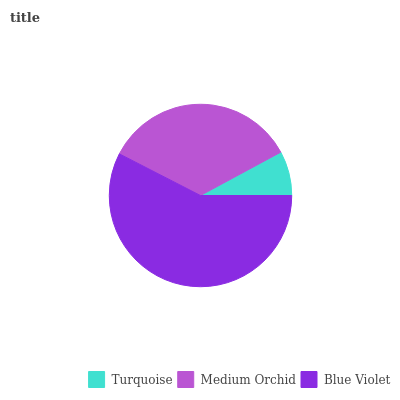Is Turquoise the minimum?
Answer yes or no. Yes. Is Blue Violet the maximum?
Answer yes or no. Yes. Is Medium Orchid the minimum?
Answer yes or no. No. Is Medium Orchid the maximum?
Answer yes or no. No. Is Medium Orchid greater than Turquoise?
Answer yes or no. Yes. Is Turquoise less than Medium Orchid?
Answer yes or no. Yes. Is Turquoise greater than Medium Orchid?
Answer yes or no. No. Is Medium Orchid less than Turquoise?
Answer yes or no. No. Is Medium Orchid the high median?
Answer yes or no. Yes. Is Medium Orchid the low median?
Answer yes or no. Yes. Is Blue Violet the high median?
Answer yes or no. No. Is Blue Violet the low median?
Answer yes or no. No. 